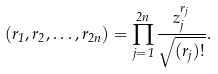<formula> <loc_0><loc_0><loc_500><loc_500>( r _ { 1 } , r _ { 2 } , \dots , r _ { 2 n } ) = \prod _ { j = 1 } ^ { 2 n } \frac { z _ { j } ^ { r _ { j } } } { \sqrt { ( r _ { j } ) ! } } .</formula> 